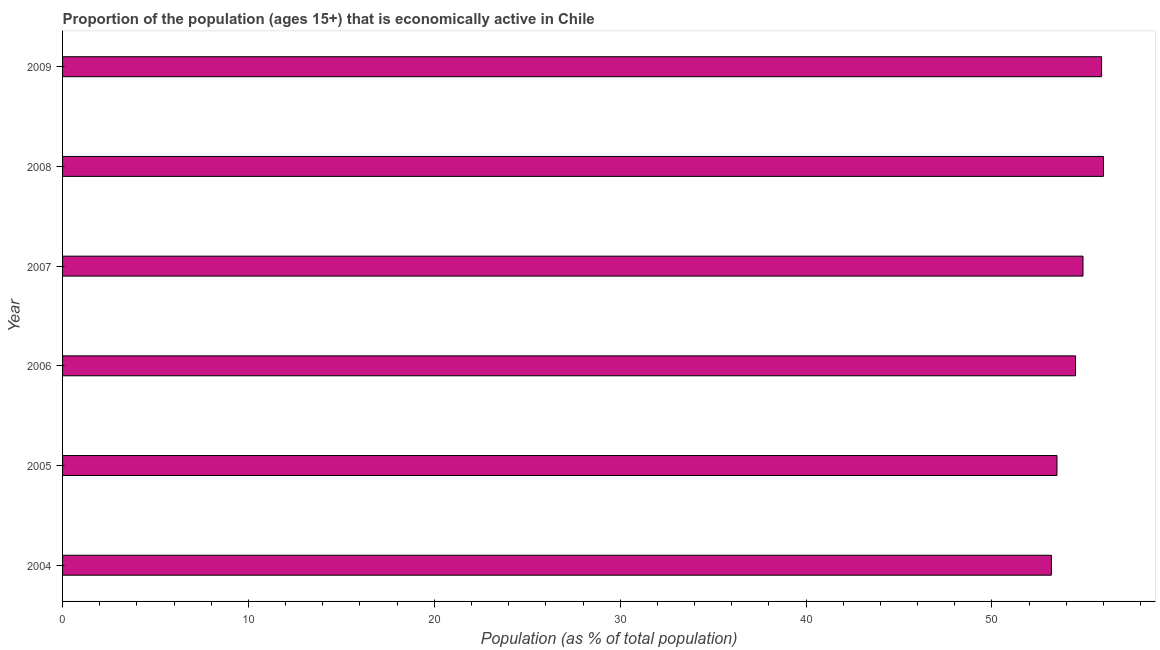Does the graph contain any zero values?
Offer a terse response. No. Does the graph contain grids?
Your answer should be very brief. No. What is the title of the graph?
Your answer should be compact. Proportion of the population (ages 15+) that is economically active in Chile. What is the label or title of the X-axis?
Your answer should be compact. Population (as % of total population). What is the label or title of the Y-axis?
Provide a short and direct response. Year. What is the percentage of economically active population in 2007?
Ensure brevity in your answer.  54.9. Across all years, what is the maximum percentage of economically active population?
Offer a terse response. 56. Across all years, what is the minimum percentage of economically active population?
Keep it short and to the point. 53.2. In which year was the percentage of economically active population maximum?
Ensure brevity in your answer.  2008. In which year was the percentage of economically active population minimum?
Your answer should be very brief. 2004. What is the sum of the percentage of economically active population?
Your answer should be compact. 328. What is the difference between the percentage of economically active population in 2008 and 2009?
Your answer should be very brief. 0.1. What is the average percentage of economically active population per year?
Your answer should be very brief. 54.67. What is the median percentage of economically active population?
Offer a very short reply. 54.7. In how many years, is the percentage of economically active population greater than 20 %?
Provide a succinct answer. 6. Is the percentage of economically active population in 2006 less than that in 2008?
Offer a very short reply. Yes. Is the sum of the percentage of economically active population in 2008 and 2009 greater than the maximum percentage of economically active population across all years?
Your answer should be compact. Yes. What is the difference between the highest and the lowest percentage of economically active population?
Your response must be concise. 2.8. In how many years, is the percentage of economically active population greater than the average percentage of economically active population taken over all years?
Make the answer very short. 3. How many bars are there?
Provide a short and direct response. 6. Are all the bars in the graph horizontal?
Your answer should be compact. Yes. What is the difference between two consecutive major ticks on the X-axis?
Your answer should be compact. 10. Are the values on the major ticks of X-axis written in scientific E-notation?
Your answer should be compact. No. What is the Population (as % of total population) of 2004?
Your answer should be compact. 53.2. What is the Population (as % of total population) in 2005?
Your response must be concise. 53.5. What is the Population (as % of total population) in 2006?
Ensure brevity in your answer.  54.5. What is the Population (as % of total population) in 2007?
Give a very brief answer. 54.9. What is the Population (as % of total population) in 2009?
Provide a short and direct response. 55.9. What is the difference between the Population (as % of total population) in 2004 and 2006?
Your answer should be very brief. -1.3. What is the difference between the Population (as % of total population) in 2005 and 2006?
Provide a short and direct response. -1. What is the difference between the Population (as % of total population) in 2006 and 2007?
Provide a short and direct response. -0.4. What is the difference between the Population (as % of total population) in 2006 and 2009?
Ensure brevity in your answer.  -1.4. What is the ratio of the Population (as % of total population) in 2004 to that in 2005?
Provide a short and direct response. 0.99. What is the ratio of the Population (as % of total population) in 2004 to that in 2007?
Offer a terse response. 0.97. What is the ratio of the Population (as % of total population) in 2005 to that in 2007?
Offer a very short reply. 0.97. What is the ratio of the Population (as % of total population) in 2005 to that in 2008?
Ensure brevity in your answer.  0.95. What is the ratio of the Population (as % of total population) in 2005 to that in 2009?
Your answer should be compact. 0.96. What is the ratio of the Population (as % of total population) in 2006 to that in 2007?
Ensure brevity in your answer.  0.99. What is the ratio of the Population (as % of total population) in 2006 to that in 2009?
Keep it short and to the point. 0.97. What is the ratio of the Population (as % of total population) in 2007 to that in 2009?
Keep it short and to the point. 0.98. 